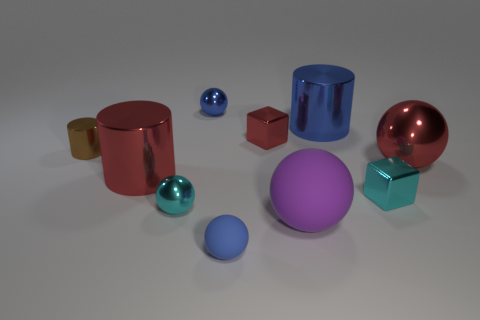What is the material of the objects and how can you tell? The objects appear to be made of a reflective material, possibly metal or plastic with a high-gloss finish. You can tell by the way the light bounces off their surfaces and creates highlights and reflections, giving them a shiny appearance. 